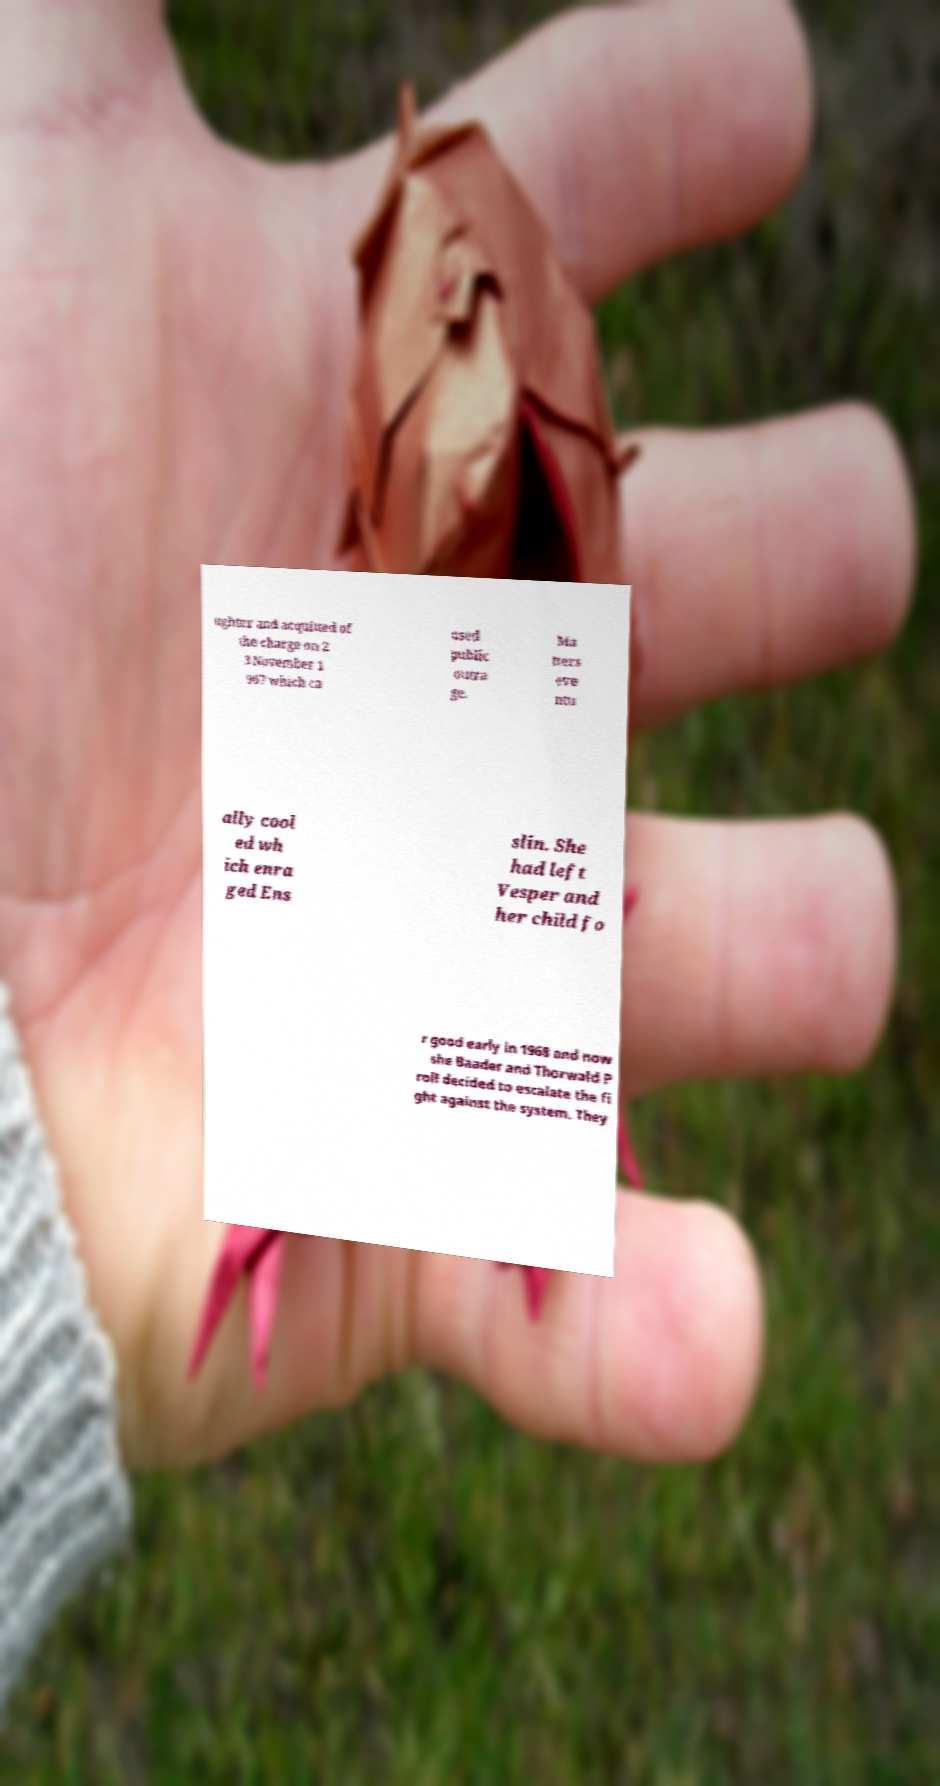Please read and relay the text visible in this image. What does it say? ughter and acquitted of the charge on 2 3 November 1 967 which ca used public outra ge. Ma tters eve ntu ally cool ed wh ich enra ged Ens slin. She had left Vesper and her child fo r good early in 1968 and now she Baader and Thorwald P roll decided to escalate the fi ght against the system. They 